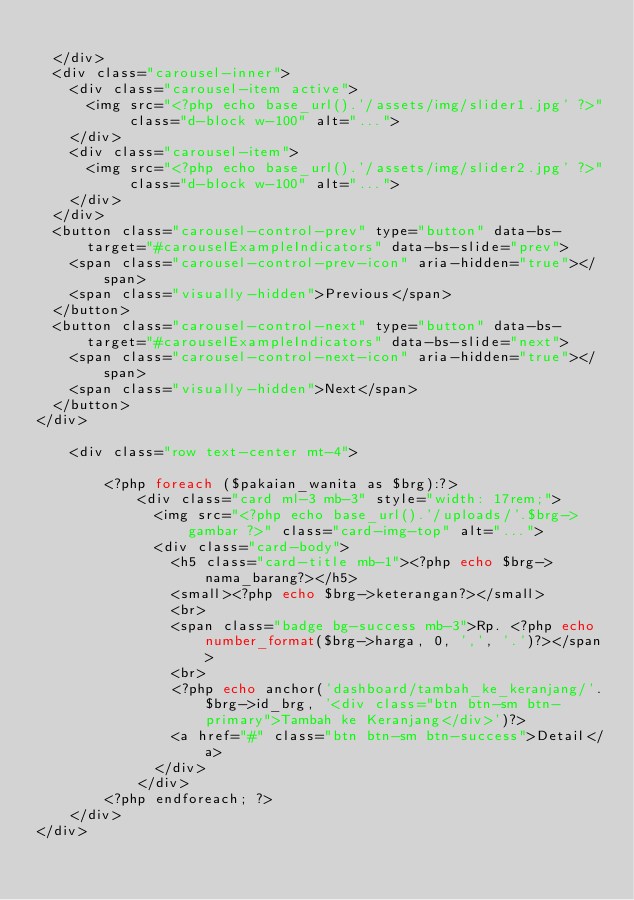<code> <loc_0><loc_0><loc_500><loc_500><_PHP_>
  </div>
  <div class="carousel-inner">
    <div class="carousel-item active">
      <img src="<?php echo base_url().'/assets/img/slider1.jpg' ?>" class="d-block w-100" alt="...">
    </div>
    <div class="carousel-item">
      <img src="<?php echo base_url().'/assets/img/slider2.jpg' ?>" class="d-block w-100" alt="...">
    </div>
  </div>
  <button class="carousel-control-prev" type="button" data-bs-target="#carouselExampleIndicators" data-bs-slide="prev">
    <span class="carousel-control-prev-icon" aria-hidden="true"></span>
    <span class="visually-hidden">Previous</span>
  </button>
  <button class="carousel-control-next" type="button" data-bs-target="#carouselExampleIndicators" data-bs-slide="next">
    <span class="carousel-control-next-icon" aria-hidden="true"></span>
    <span class="visually-hidden">Next</span>
  </button>
</div>

    <div class="row text-center mt-4">
        
        <?php foreach ($pakaian_wanita as $brg):?>
            <div class="card ml-3 mb-3" style="width: 17rem;">
              <img src="<?php echo base_url().'/uploads/'.$brg->gambar ?>" class="card-img-top" alt="...">
              <div class="card-body">
                <h5 class="card-title mb-1"><?php echo $brg->nama_barang?></h5>
                <small><?php echo $brg->keterangan?></small>
                <br>
                <span class="badge bg-success mb-3">Rp. <?php echo number_format($brg->harga, 0, ',', '.')?></span>
                <br>
                <?php echo anchor('dashboard/tambah_ke_keranjang/'.$brg->id_brg, '<div class="btn btn-sm btn-primary">Tambah ke Keranjang</div>')?>
                <a href="#" class="btn btn-sm btn-success">Detail</a>
              </div>
            </div>
        <?php endforeach; ?>
    </div>
</div></code> 